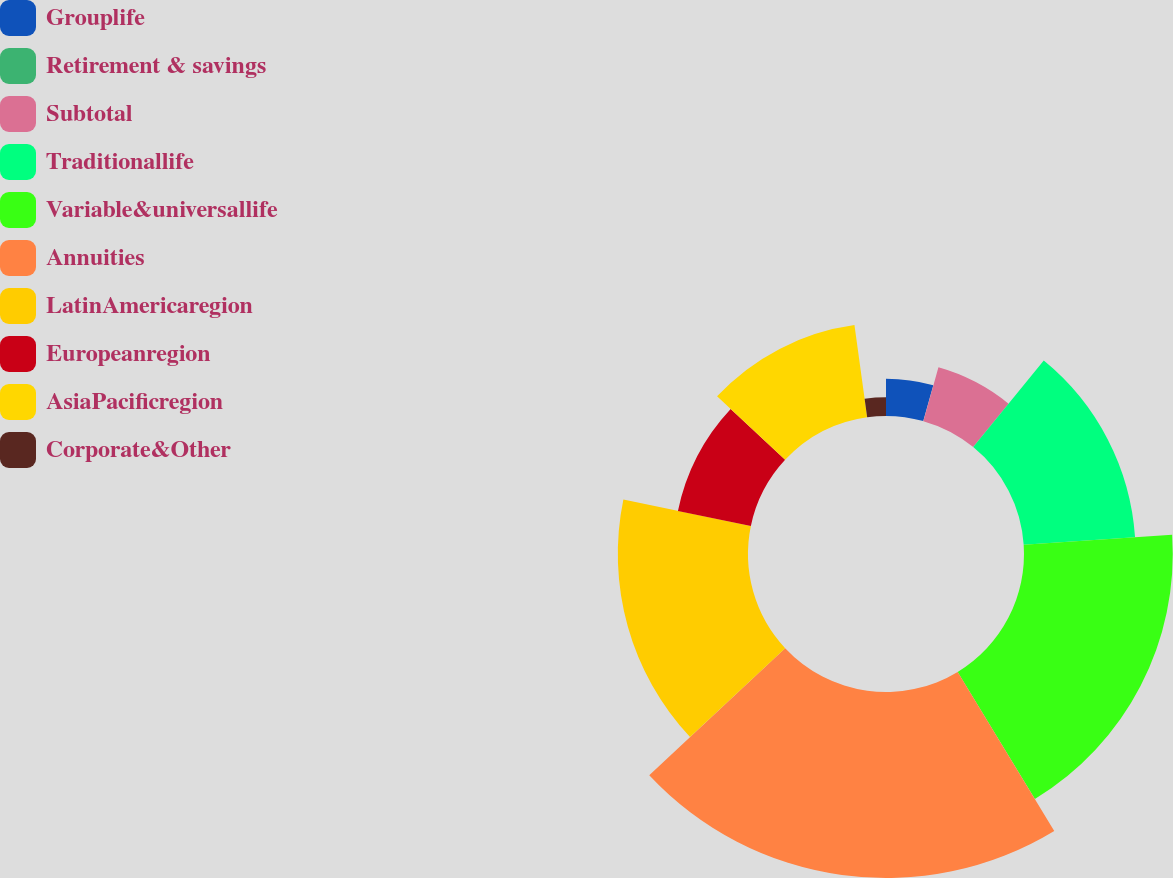Convert chart to OTSL. <chart><loc_0><loc_0><loc_500><loc_500><pie_chart><fcel>Grouplife<fcel>Retirement & savings<fcel>Subtotal<fcel>Traditionallife<fcel>Variable&universallife<fcel>Annuities<fcel>LatinAmericaregion<fcel>Europeanregion<fcel>AsiaPacificregion<fcel>Corporate&Other<nl><fcel>4.35%<fcel>0.01%<fcel>6.53%<fcel>13.04%<fcel>17.38%<fcel>21.73%<fcel>15.21%<fcel>8.7%<fcel>10.87%<fcel>2.18%<nl></chart> 